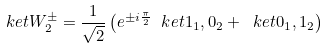<formula> <loc_0><loc_0><loc_500><loc_500>\ k e t { W _ { 2 } ^ { \pm } } = \frac { 1 } { \sqrt { 2 } } \left ( e ^ { \pm i \frac { \pi } { 2 } } \ k e t { 1 _ { 1 } , 0 _ { 2 } } + \ k e t { 0 _ { 1 } , 1 _ { 2 } } \right )</formula> 